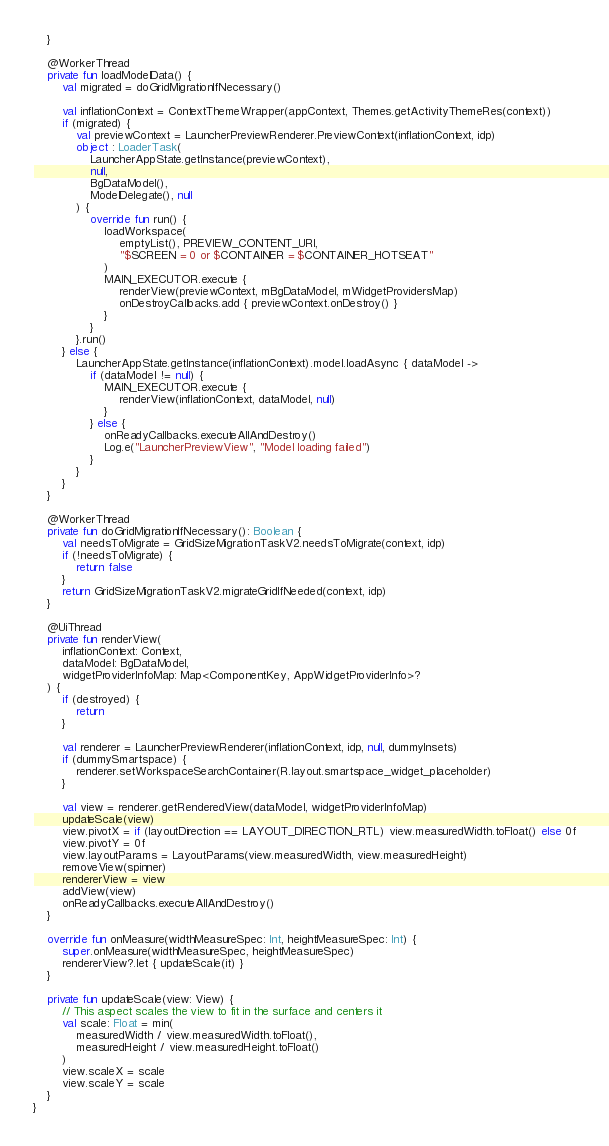Convert code to text. <code><loc_0><loc_0><loc_500><loc_500><_Kotlin_>    }

    @WorkerThread
    private fun loadModelData() {
        val migrated = doGridMigrationIfNecessary()

        val inflationContext = ContextThemeWrapper(appContext, Themes.getActivityThemeRes(context))
        if (migrated) {
            val previewContext = LauncherPreviewRenderer.PreviewContext(inflationContext, idp)
            object : LoaderTask(
                LauncherAppState.getInstance(previewContext),
                null,
                BgDataModel(),
                ModelDelegate(), null
            ) {
                override fun run() {
                    loadWorkspace(
                        emptyList(), PREVIEW_CONTENT_URI,
                        "$SCREEN = 0 or $CONTAINER = $CONTAINER_HOTSEAT"
                    )
                    MAIN_EXECUTOR.execute {
                        renderView(previewContext, mBgDataModel, mWidgetProvidersMap)
                        onDestroyCallbacks.add { previewContext.onDestroy() }
                    }
                }
            }.run()
        } else {
            LauncherAppState.getInstance(inflationContext).model.loadAsync { dataModel ->
                if (dataModel != null) {
                    MAIN_EXECUTOR.execute {
                        renderView(inflationContext, dataModel, null)
                    }
                } else {
                    onReadyCallbacks.executeAllAndDestroy()
                    Log.e("LauncherPreviewView", "Model loading failed")
                }
            }
        }
    }

    @WorkerThread
    private fun doGridMigrationIfNecessary(): Boolean {
        val needsToMigrate = GridSizeMigrationTaskV2.needsToMigrate(context, idp)
        if (!needsToMigrate) {
            return false
        }
        return GridSizeMigrationTaskV2.migrateGridIfNeeded(context, idp)
    }

    @UiThread
    private fun renderView(
        inflationContext: Context,
        dataModel: BgDataModel,
        widgetProviderInfoMap: Map<ComponentKey, AppWidgetProviderInfo>?
    ) {
        if (destroyed) {
            return
        }

        val renderer = LauncherPreviewRenderer(inflationContext, idp, null, dummyInsets)
        if (dummySmartspace) {
            renderer.setWorkspaceSearchContainer(R.layout.smartspace_widget_placeholder)
        }

        val view = renderer.getRenderedView(dataModel, widgetProviderInfoMap)
        updateScale(view)
        view.pivotX = if (layoutDirection == LAYOUT_DIRECTION_RTL) view.measuredWidth.toFloat() else 0f
        view.pivotY = 0f
        view.layoutParams = LayoutParams(view.measuredWidth, view.measuredHeight)
        removeView(spinner)
        rendererView = view
        addView(view)
        onReadyCallbacks.executeAllAndDestroy()
    }

    override fun onMeasure(widthMeasureSpec: Int, heightMeasureSpec: Int) {
        super.onMeasure(widthMeasureSpec, heightMeasureSpec)
        rendererView?.let { updateScale(it) }
    }

    private fun updateScale(view: View) {
        // This aspect scales the view to fit in the surface and centers it
        val scale: Float = min(
            measuredWidth / view.measuredWidth.toFloat(),
            measuredHeight / view.measuredHeight.toFloat()
        )
        view.scaleX = scale
        view.scaleY = scale
    }
}
</code> 